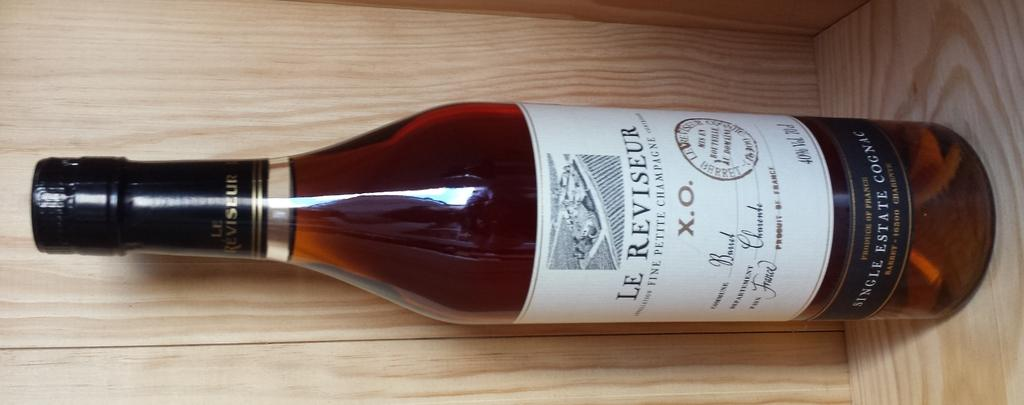<image>
Summarize the visual content of the image. A bottle of Le Reviseur Fine Petite Champagne is shown sideways on wooden surface. 